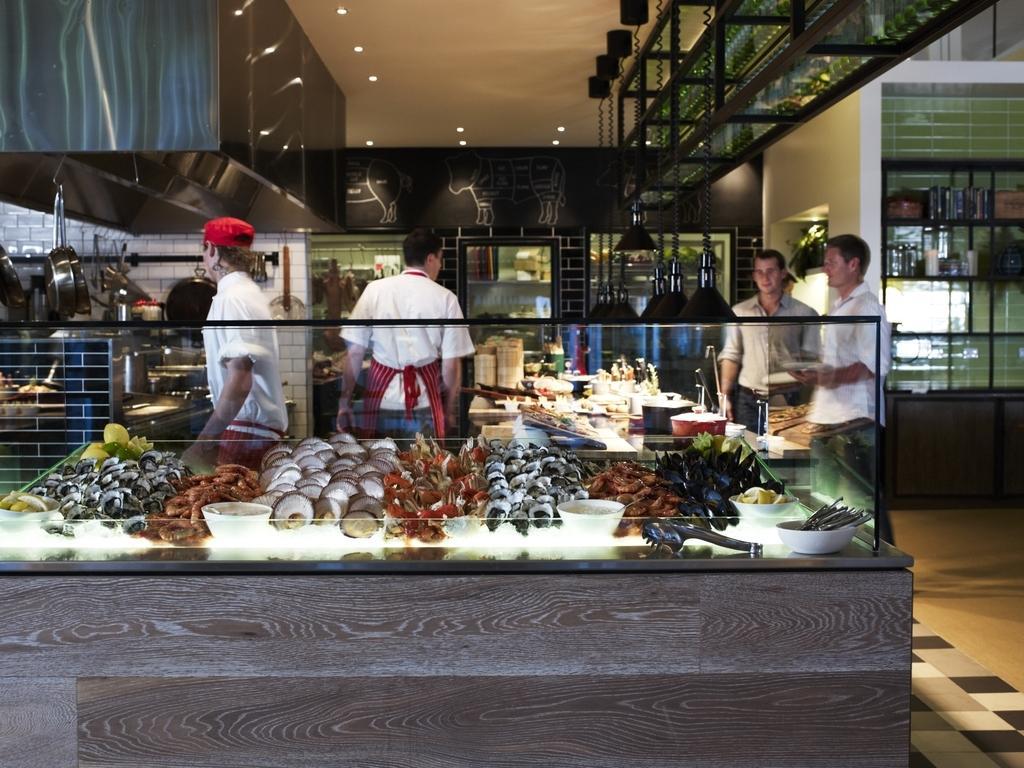Please provide a concise description of this image. In this picture I can see there are two people standing at the left side and there are some food, plates, utensils, spoons and there are few lights attached to the ceiling. The people standing at the left side are wearing aprons and there are two people standing at the right side. 